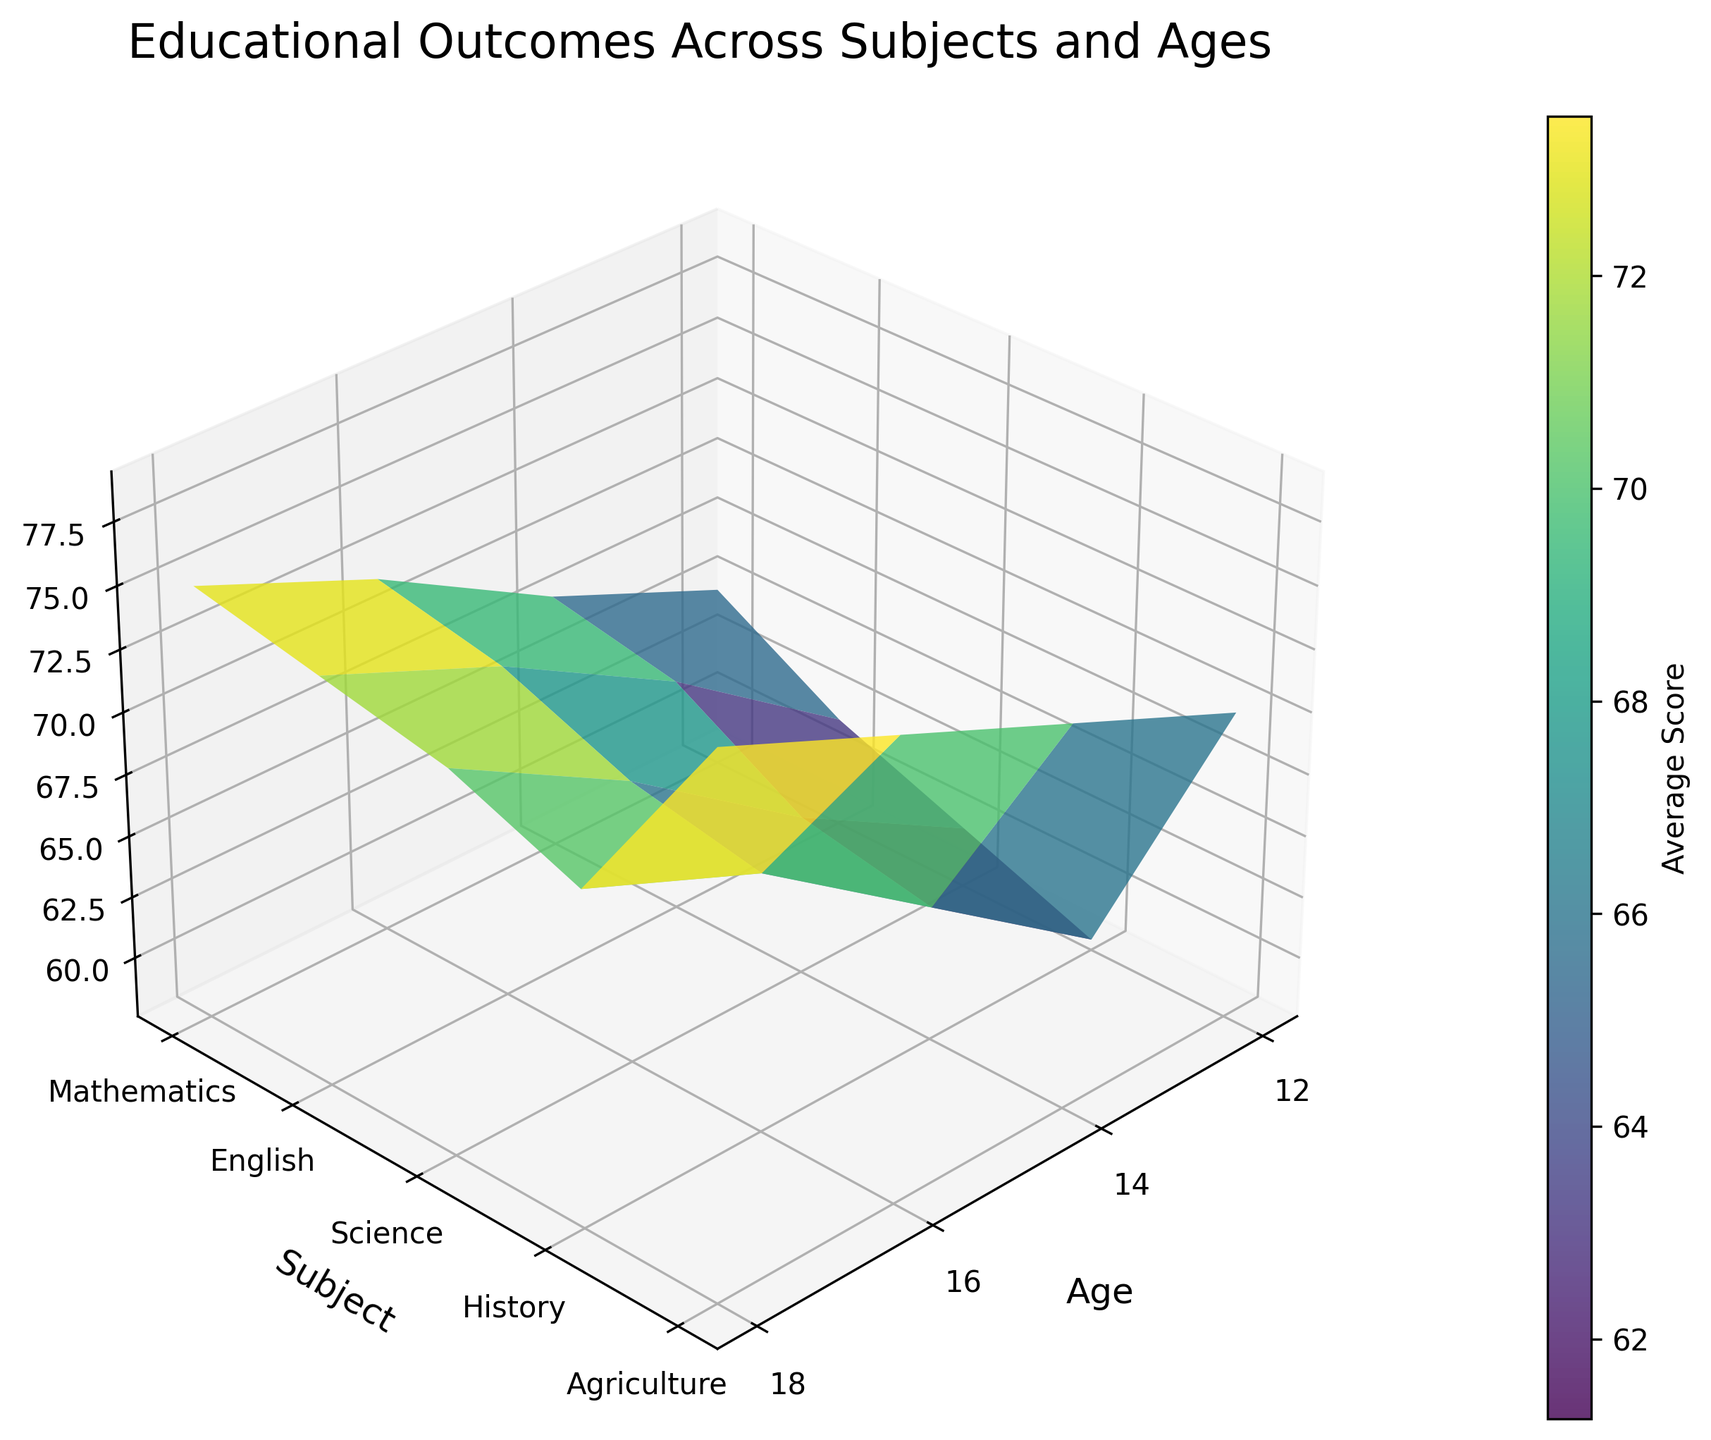What is the title of the figure? The title of the figure can be found at the top of the plot. It describes what the visualization represents.
Answer: Educational Outcomes Across Subjects and Ages What does the color bar represent? The color bar is a visual guide often located next to the 3D surface plot. It indicates what the colors on the plot correspond to in terms of data values.
Answer: Average Score Which subject has the highest average score for the age group 18? To answer this, look at the topmost z-values for age 18 on the y-axis labeled "Subject."
Answer: Agriculture How does the average score in English change as students age from 12 to 18? Examine the surface plot's heights (z-values) along the English y-tick label at different x-tick labels for ages 12 to 18.
Answer: Increases from 62 to 74 What subject shows the highest increase in average scores from age 12 to 18? Identify the z-value differences between ages 12 and 18 for all subjects and select the subject with the largest increase.
Answer: Agriculture On average, is the score in Science higher or lower than in History across all ages? Compare the average heights (z-values) of Science and History data points across all age groups.
Answer: Higher Which age group sees the most significant jump in scores for Mathematics, and by how much? Compare the differences in z-values for Mathematics between each consecutive age group and identify the largest difference.
Answer: From 14 to 16, by 4 points Are the average scores for History consistently the lowest across all age groups? Compare the heights (z-values) at each age tick for History and other subjects to see if History remains the lowest.
Answer: No Which subject has the smallest range of average scores across all ages? Determine the difference between the highest and lowest z-values within each subject and identify the subject with the smallest difference.
Answer: History Based on the 3D plot, can it be inferred that older students tend to have higher average scores in all subjects? Observe if the heights (z-values) generally increase from left to right for each subject's y-tick label.
Answer: Yes 